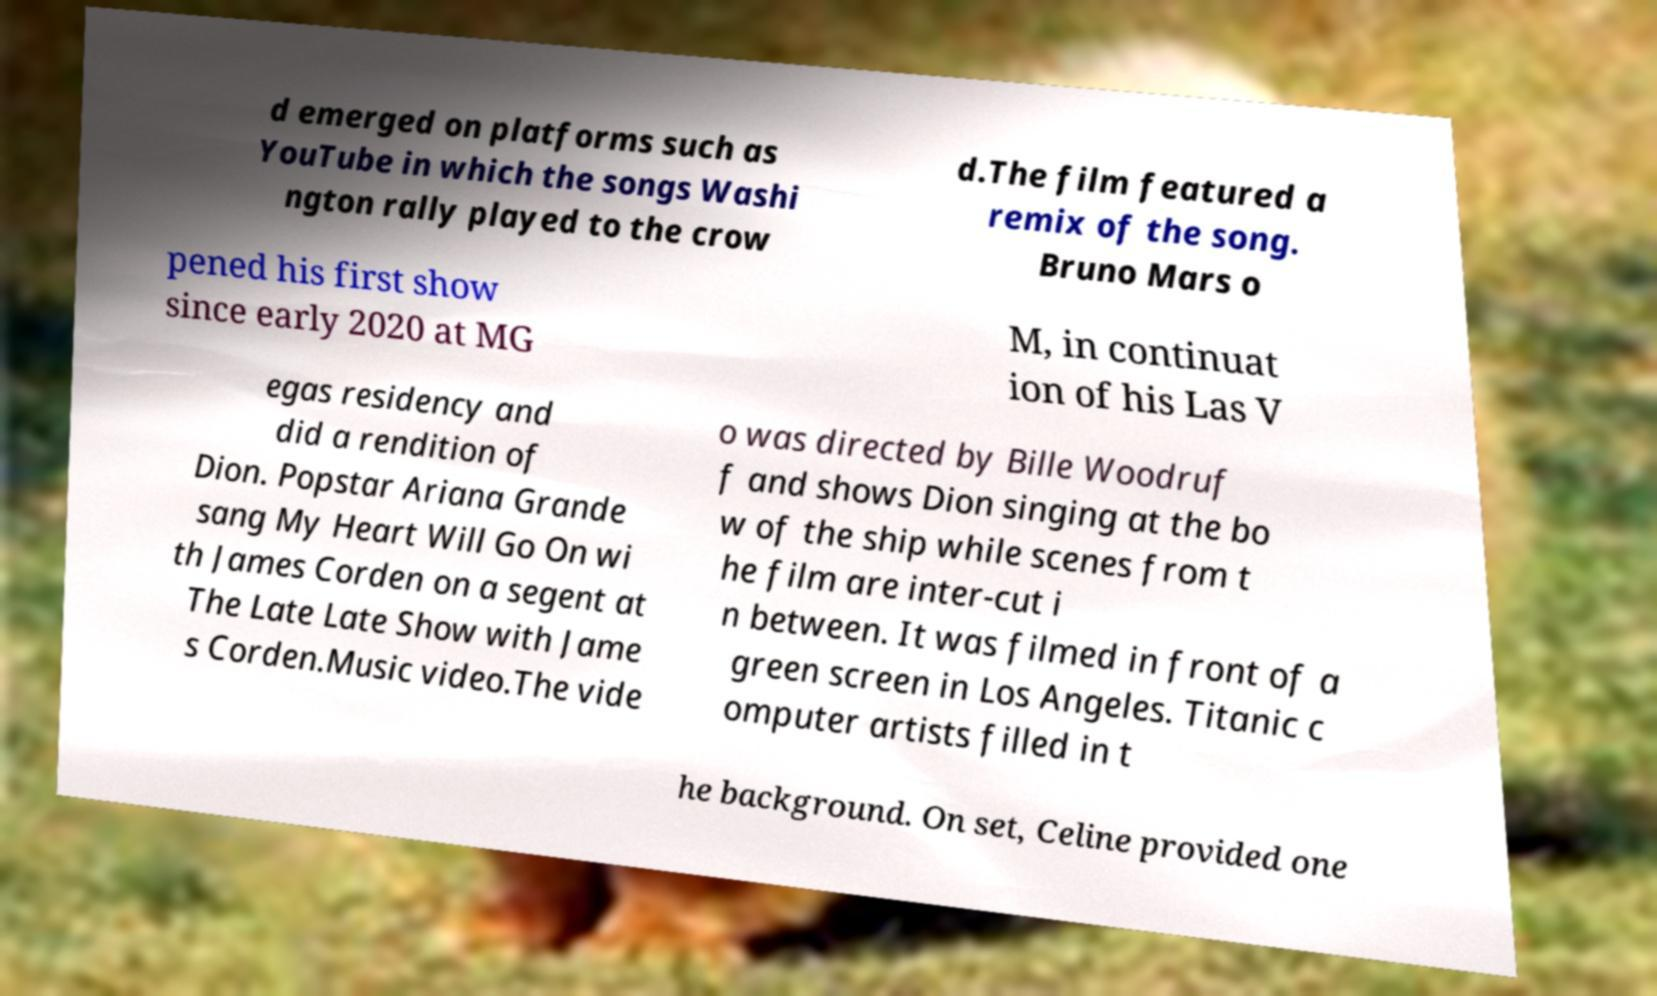There's text embedded in this image that I need extracted. Can you transcribe it verbatim? d emerged on platforms such as YouTube in which the songs Washi ngton rally played to the crow d.The film featured a remix of the song. Bruno Mars o pened his first show since early 2020 at MG M, in continuat ion of his Las V egas residency and did a rendition of Dion. Popstar Ariana Grande sang My Heart Will Go On wi th James Corden on a segent at The Late Late Show with Jame s Corden.Music video.The vide o was directed by Bille Woodruf f and shows Dion singing at the bo w of the ship while scenes from t he film are inter-cut i n between. It was filmed in front of a green screen in Los Angeles. Titanic c omputer artists filled in t he background. On set, Celine provided one 